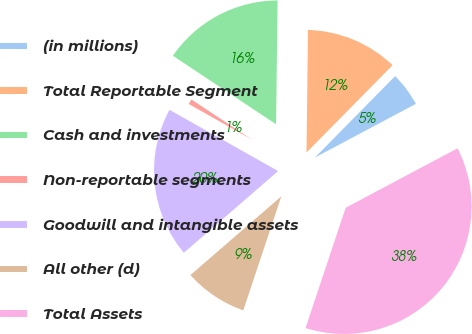<chart> <loc_0><loc_0><loc_500><loc_500><pie_chart><fcel>(in millions)<fcel>Total Reportable Segment<fcel>Cash and investments<fcel>Non-reportable segments<fcel>Goodwill and intangible assets<fcel>All other (d)<fcel>Total Assets<nl><fcel>4.84%<fcel>12.19%<fcel>15.86%<fcel>1.16%<fcel>19.53%<fcel>8.51%<fcel>37.9%<nl></chart> 